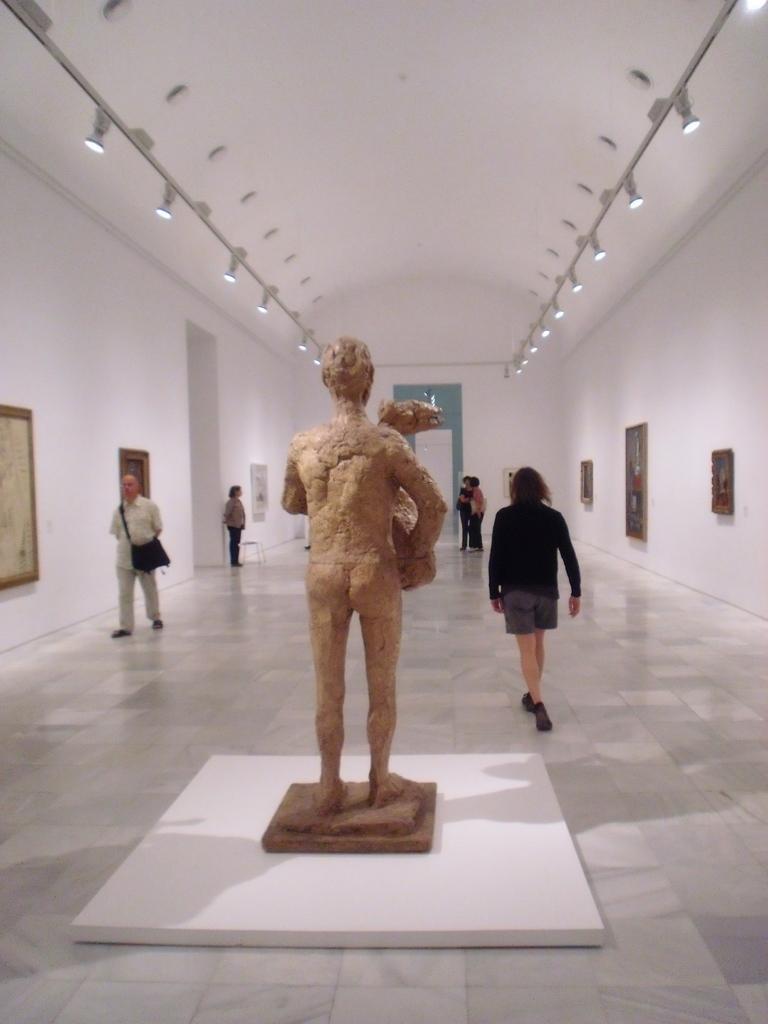In one or two sentences, can you explain what this image depicts? In this picture we can see a sculpture and in front of the sculpture there are two people walking on the floor and other people are standing. On the left and right side of the people there are wall with photo frames and on the top there are ceiling lights. 